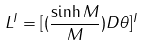<formula> <loc_0><loc_0><loc_500><loc_500>L ^ { I } = [ ( \frac { \sinh M } { M } ) D \theta ] ^ { I }</formula> 